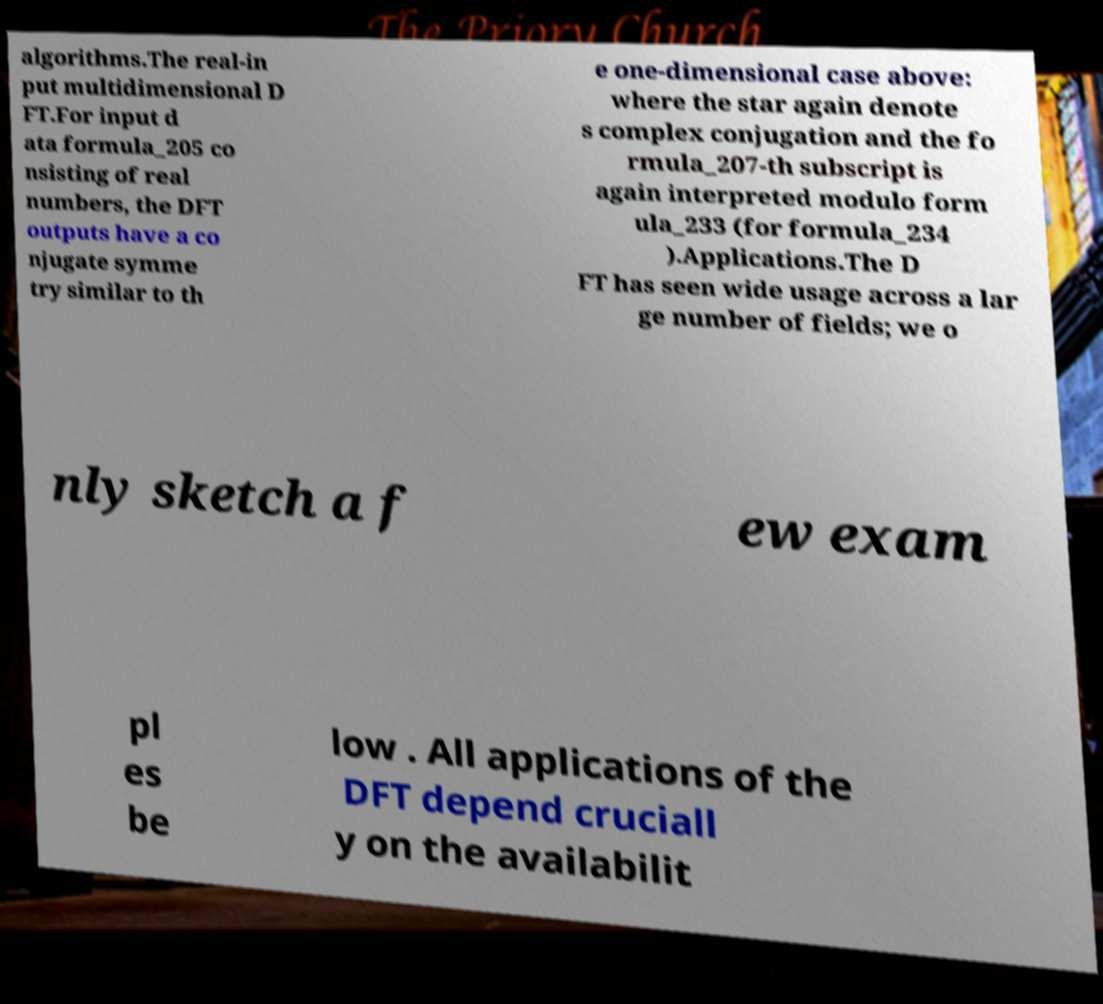Could you extract and type out the text from this image? algorithms.The real-in put multidimensional D FT.For input d ata formula_205 co nsisting of real numbers, the DFT outputs have a co njugate symme try similar to th e one-dimensional case above: where the star again denote s complex conjugation and the fo rmula_207-th subscript is again interpreted modulo form ula_233 (for formula_234 ).Applications.The D FT has seen wide usage across a lar ge number of fields; we o nly sketch a f ew exam pl es be low . All applications of the DFT depend cruciall y on the availabilit 